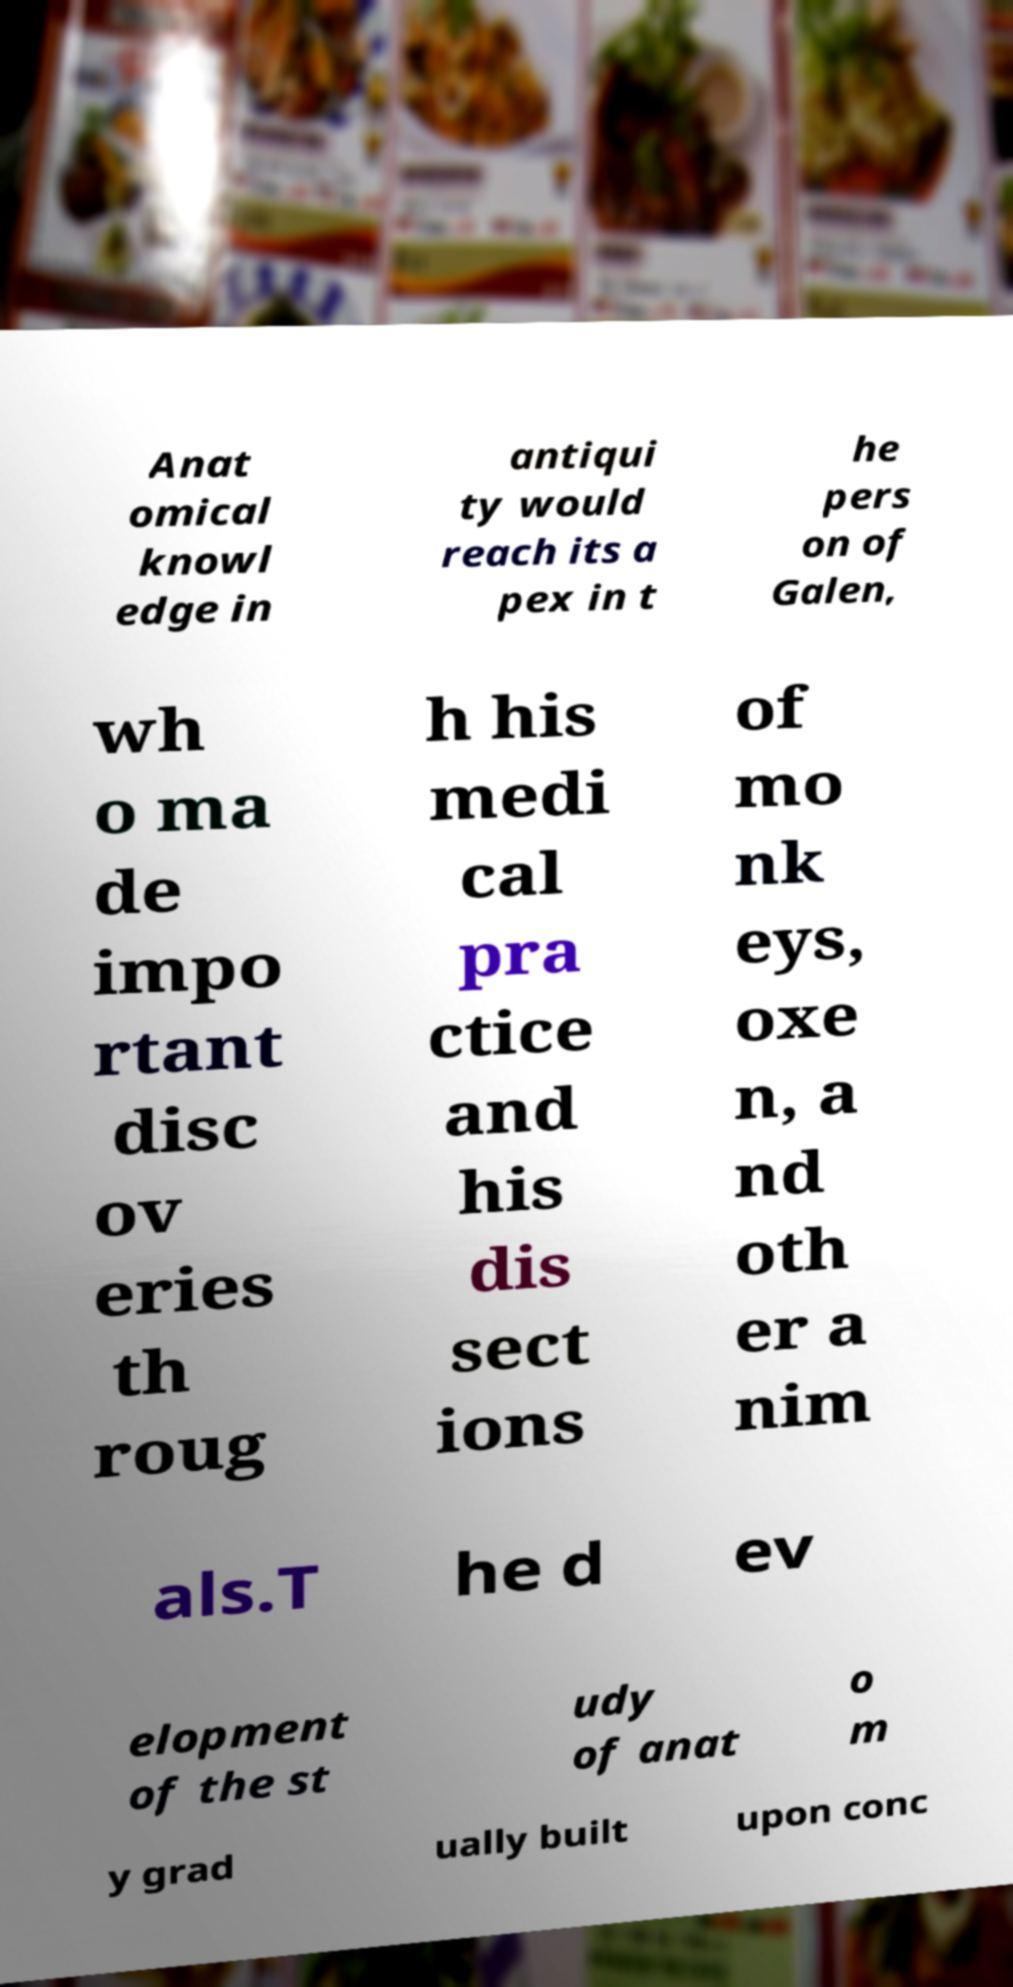Please identify and transcribe the text found in this image. Anat omical knowl edge in antiqui ty would reach its a pex in t he pers on of Galen, wh o ma de impo rtant disc ov eries th roug h his medi cal pra ctice and his dis sect ions of mo nk eys, oxe n, a nd oth er a nim als.T he d ev elopment of the st udy of anat o m y grad ually built upon conc 